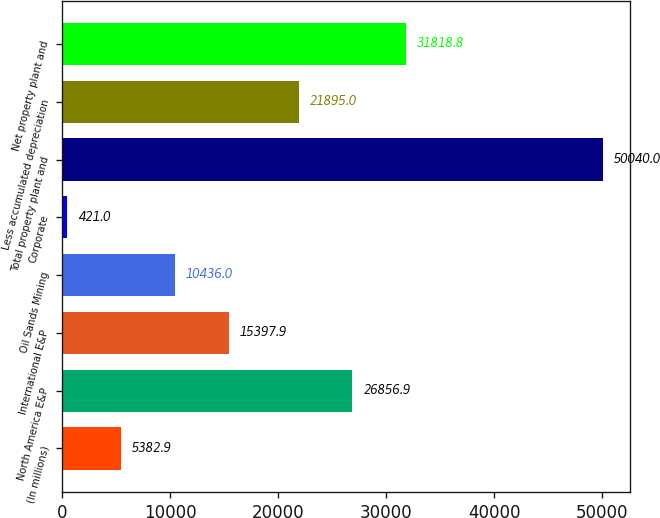Convert chart to OTSL. <chart><loc_0><loc_0><loc_500><loc_500><bar_chart><fcel>(In millions)<fcel>North America E&P<fcel>International E&P<fcel>Oil Sands Mining<fcel>Corporate<fcel>Total property plant and<fcel>Less accumulated depreciation<fcel>Net property plant and<nl><fcel>5382.9<fcel>26856.9<fcel>15397.9<fcel>10436<fcel>421<fcel>50040<fcel>21895<fcel>31818.8<nl></chart> 